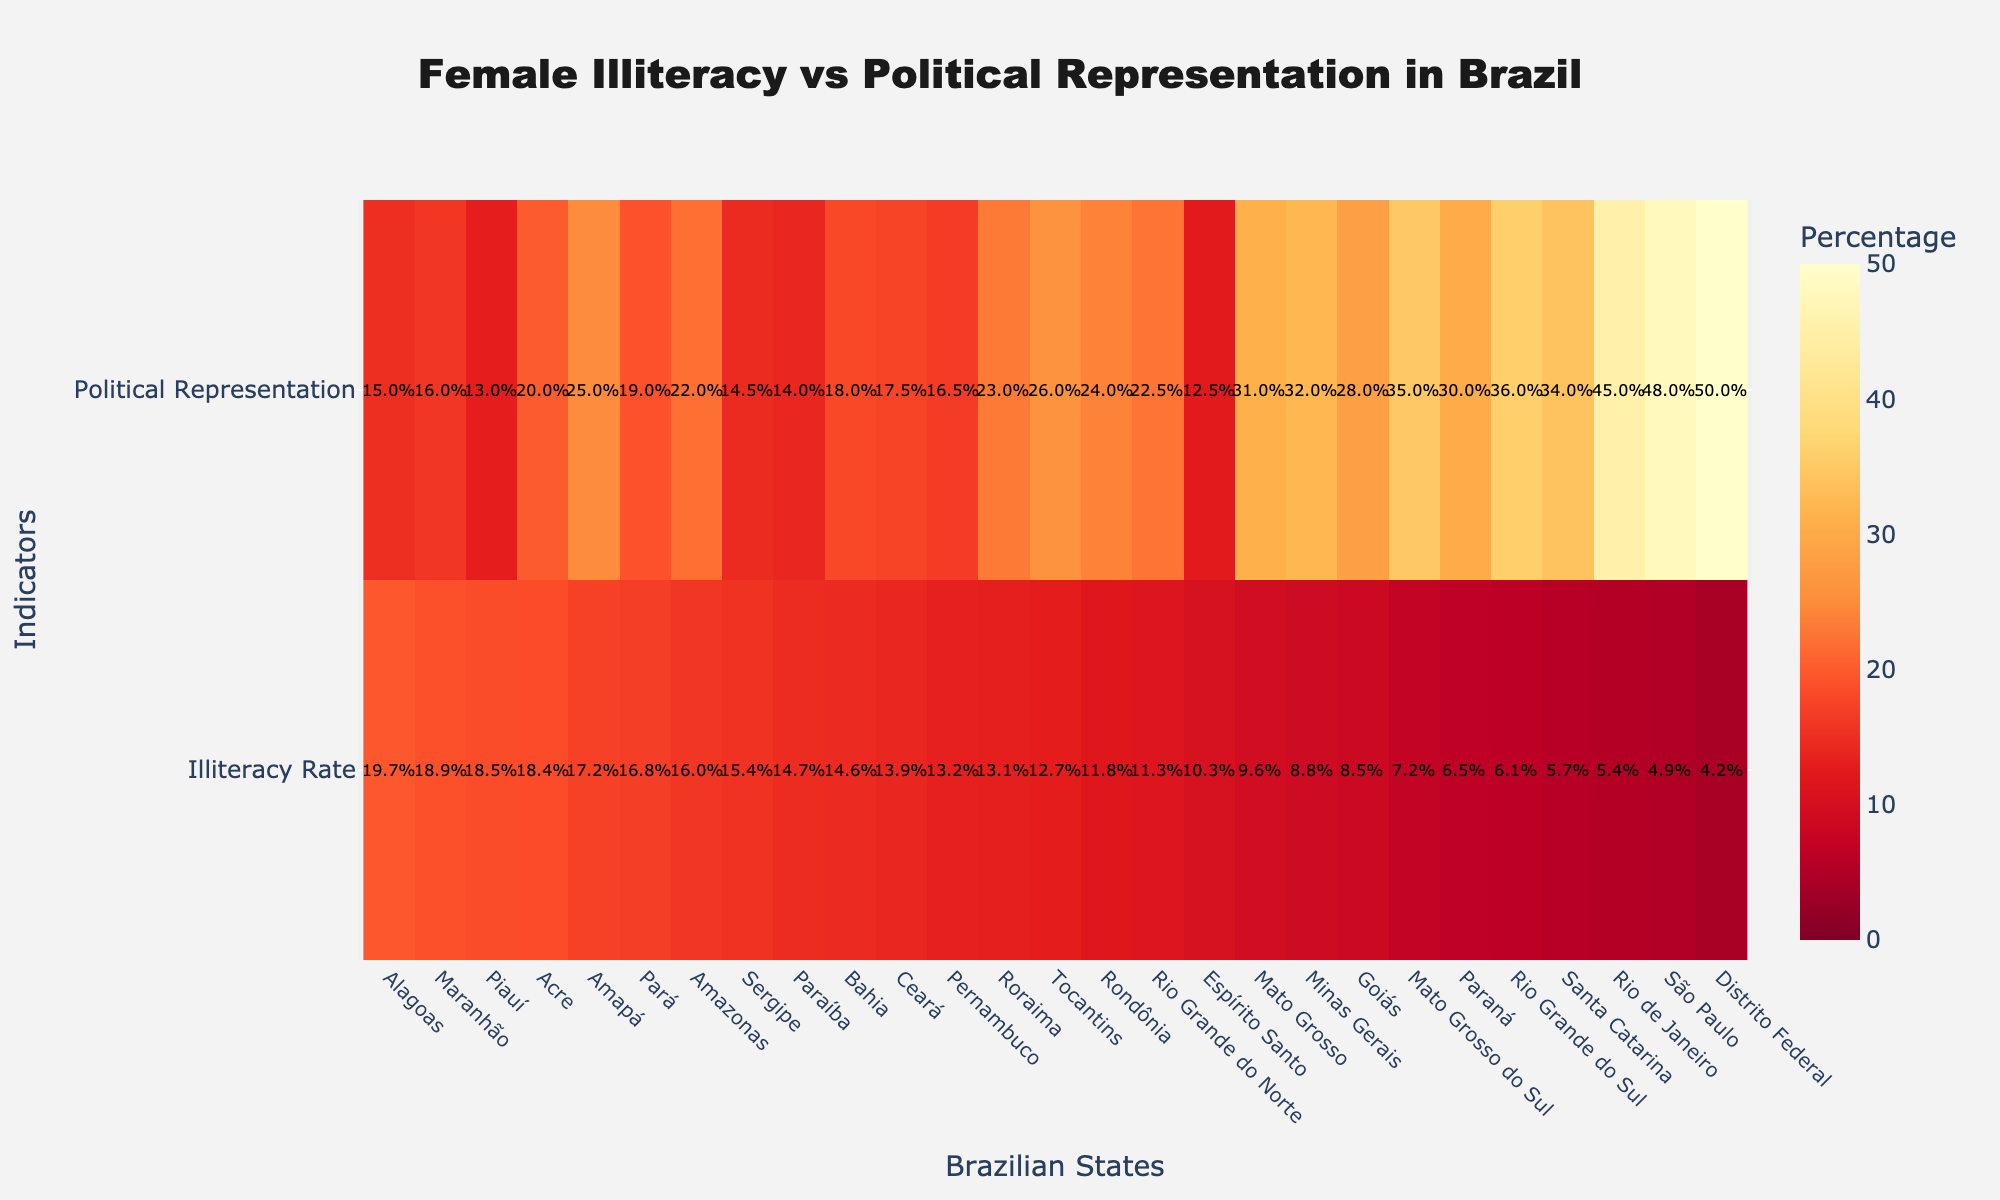What is the title of the heatmap? The title is usually displayed prominently at the top of the figure. It helps the viewer quickly understand the main topic of the visualization.
Answer: Female Illiteracy vs Political Representation in Brazil Which state has the highest female illiteracy rate? To find the state with the highest female illiteracy rate, examine the "Illiteracy Rate" row and identify the state with the darkest color, indicating the highest percentage.
Answer: Maranhão Which state has the lowest female political representation? To identify the state with the lowest female political representation, look for the state with the least intense color in the "Political Representation" row.
Answer: Espírito Santo What is the illiteracy rate and political representation in Distrito Federal? Locate Distrito Federal on the x-axis, then refer to the annotations in both the "Illiteracy Rate" and "Political Representation" rows for the respective percentages.
Answer: 4.2%, 50.0% Compare the illiteracy rates between Rio de Janeiro and São Paulo. Find Rio de Janeiro and São Paulo on the x-axis, then compare the annotated percentages in the "Illiteracy Rate" row for both states.
Answer: Rio de Janeiro: 5.4%, São Paulo: 4.9% Which state shows the highest political representation among the top three states with the highest illiteracy rates? Identify the top three states with the highest illiteracy rates by examining the darkest regions in the "Illiteracy Rate" row. Then, compare their corresponding values in the "Political Representation" row.
Answer: Acre with 20.0% What is the difference in illiteracy rates between Pernambuco and Paraná? Locate Pernambuco and Paraná on the x-axis, then subtract the illiteracy rate of Paraná from that of Pernambuco.
Answer: 13.2% - 6.5% = 6.7% Is there a state with both low illiteracy and high political representation? Look for states with lighter colors in the "Illiteracy Rate" row and darker colors in the "Political Representation" row.
Answer: Distrito Federal (4.2%, 50.0%) Which region (North, Northeast, South, Southeast, Central-West) generally shows higher female political representation? Aggregate the states by their regions, comparing the intensity of the colors in the "Political Representation" row for states in each region.
Answer: Southeast and Central-West What is the average female political representation among the states with an illiteracy rate below 10%? Identify states with an illiteracy rate below 10% and calculate the average of their political representation values.
Answer: (50.0 + 28.0 + 31.0 + 35.0 + 32.0 + 45.0 + 36.0 + 34.0 + 48.0) / 9 = 37.7% 